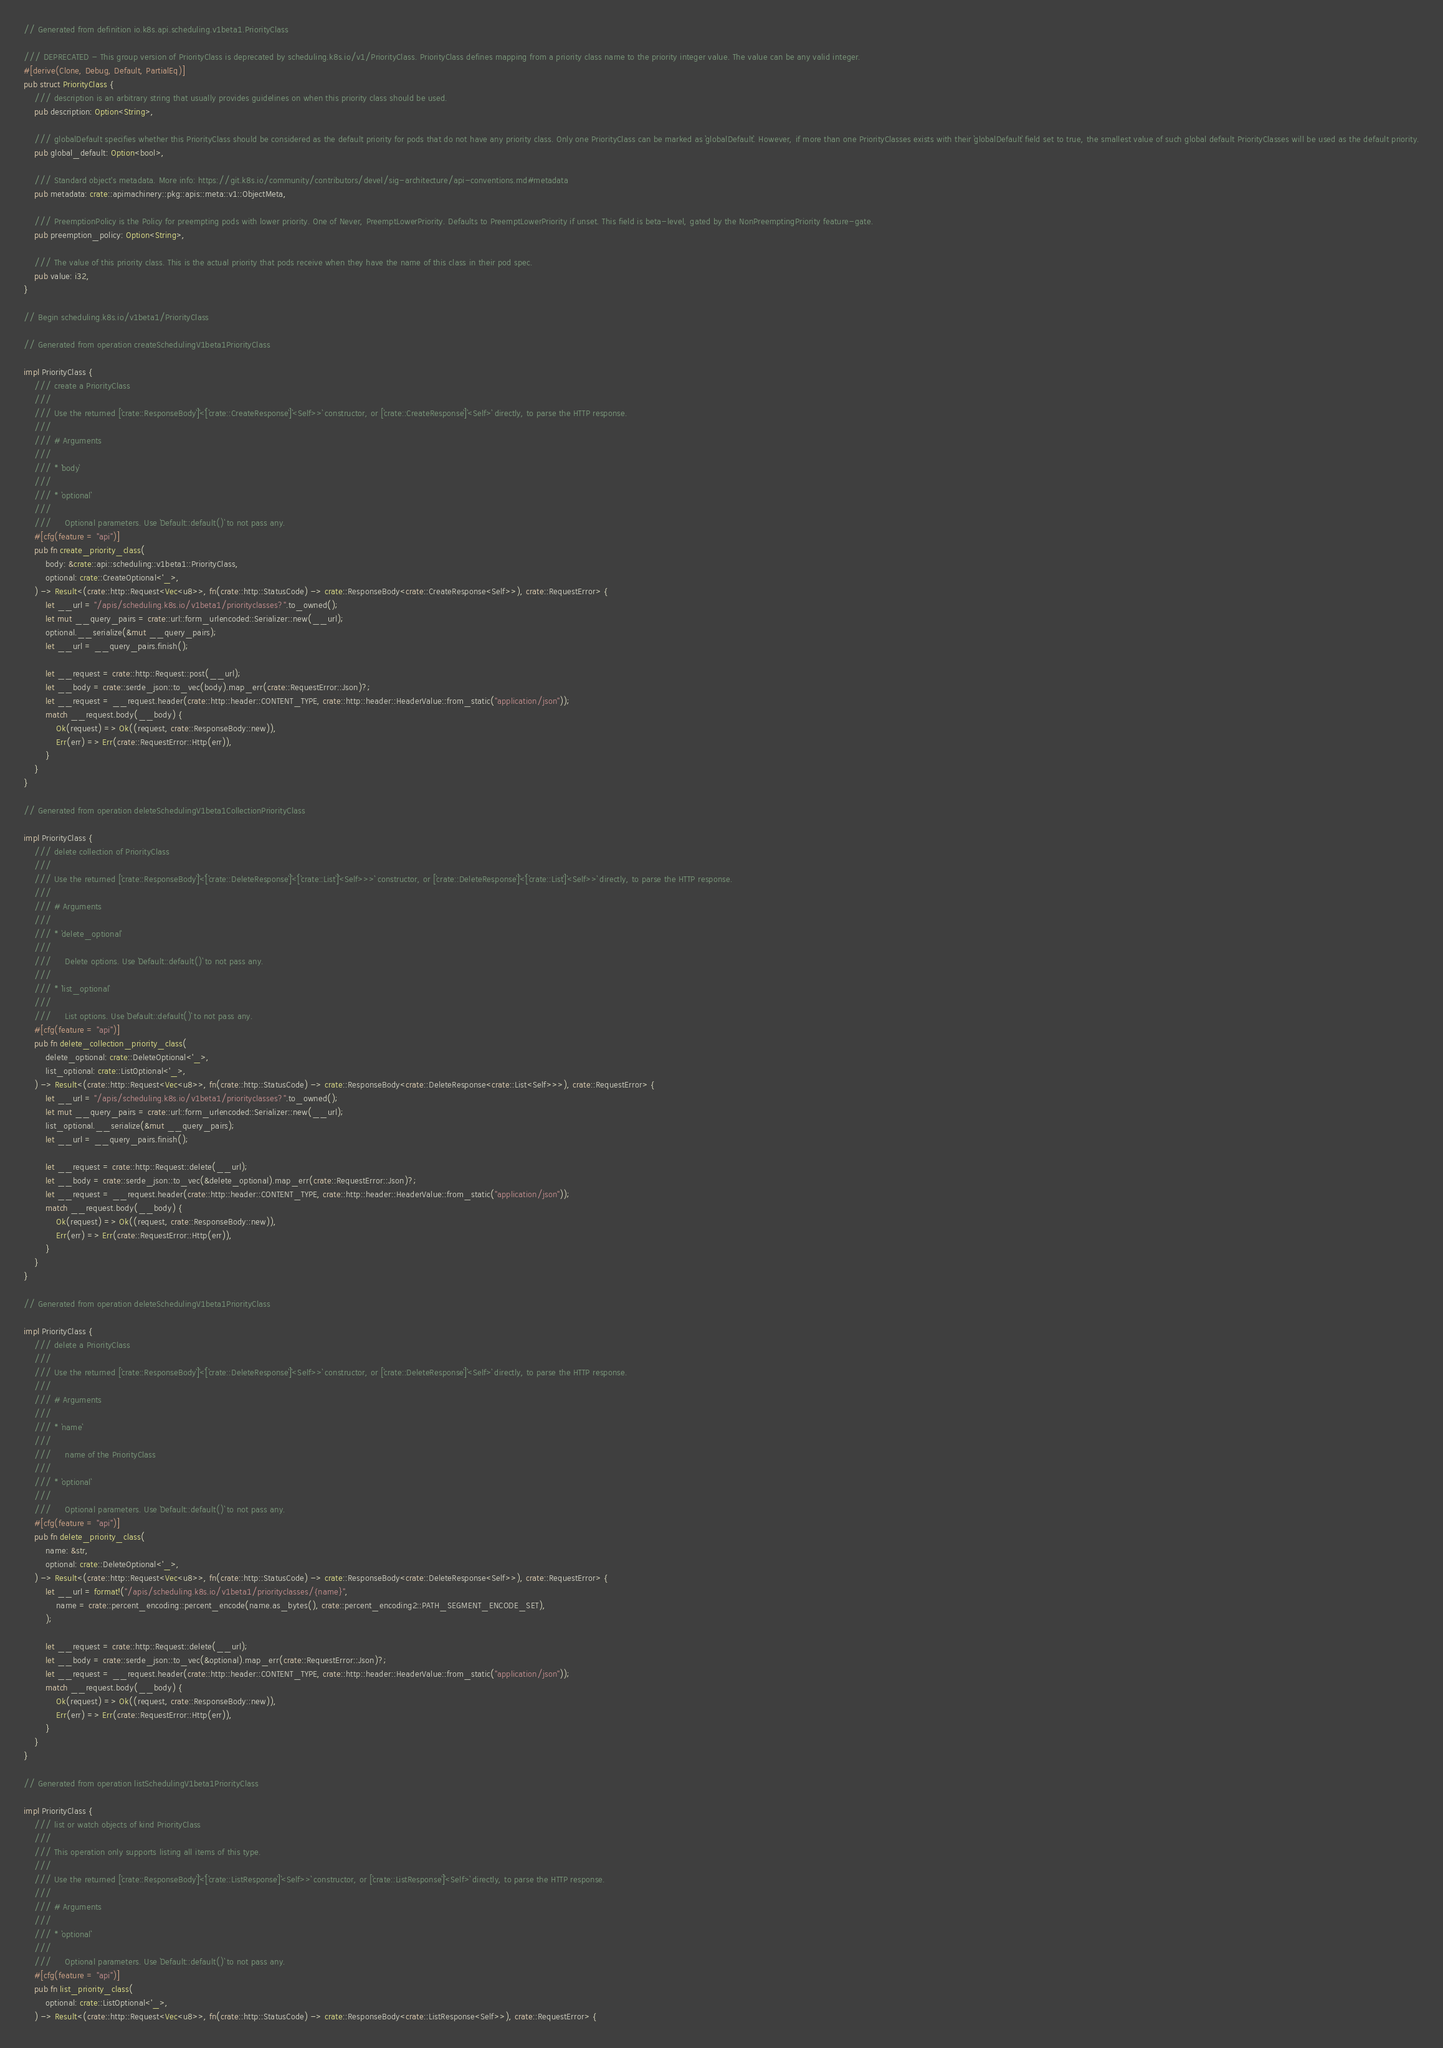<code> <loc_0><loc_0><loc_500><loc_500><_Rust_>// Generated from definition io.k8s.api.scheduling.v1beta1.PriorityClass

/// DEPRECATED - This group version of PriorityClass is deprecated by scheduling.k8s.io/v1/PriorityClass. PriorityClass defines mapping from a priority class name to the priority integer value. The value can be any valid integer.
#[derive(Clone, Debug, Default, PartialEq)]
pub struct PriorityClass {
    /// description is an arbitrary string that usually provides guidelines on when this priority class should be used.
    pub description: Option<String>,

    /// globalDefault specifies whether this PriorityClass should be considered as the default priority for pods that do not have any priority class. Only one PriorityClass can be marked as `globalDefault`. However, if more than one PriorityClasses exists with their `globalDefault` field set to true, the smallest value of such global default PriorityClasses will be used as the default priority.
    pub global_default: Option<bool>,

    /// Standard object's metadata. More info: https://git.k8s.io/community/contributors/devel/sig-architecture/api-conventions.md#metadata
    pub metadata: crate::apimachinery::pkg::apis::meta::v1::ObjectMeta,

    /// PreemptionPolicy is the Policy for preempting pods with lower priority. One of Never, PreemptLowerPriority. Defaults to PreemptLowerPriority if unset. This field is beta-level, gated by the NonPreemptingPriority feature-gate.
    pub preemption_policy: Option<String>,

    /// The value of this priority class. This is the actual priority that pods receive when they have the name of this class in their pod spec.
    pub value: i32,
}

// Begin scheduling.k8s.io/v1beta1/PriorityClass

// Generated from operation createSchedulingV1beta1PriorityClass

impl PriorityClass {
    /// create a PriorityClass
    ///
    /// Use the returned [`crate::ResponseBody`]`<`[`crate::CreateResponse`]`<Self>>` constructor, or [`crate::CreateResponse`]`<Self>` directly, to parse the HTTP response.
    ///
    /// # Arguments
    ///
    /// * `body`
    ///
    /// * `optional`
    ///
    ///     Optional parameters. Use `Default::default()` to not pass any.
    #[cfg(feature = "api")]
    pub fn create_priority_class(
        body: &crate::api::scheduling::v1beta1::PriorityClass,
        optional: crate::CreateOptional<'_>,
    ) -> Result<(crate::http::Request<Vec<u8>>, fn(crate::http::StatusCode) -> crate::ResponseBody<crate::CreateResponse<Self>>), crate::RequestError> {
        let __url = "/apis/scheduling.k8s.io/v1beta1/priorityclasses?".to_owned();
        let mut __query_pairs = crate::url::form_urlencoded::Serializer::new(__url);
        optional.__serialize(&mut __query_pairs);
        let __url = __query_pairs.finish();

        let __request = crate::http::Request::post(__url);
        let __body = crate::serde_json::to_vec(body).map_err(crate::RequestError::Json)?;
        let __request = __request.header(crate::http::header::CONTENT_TYPE, crate::http::header::HeaderValue::from_static("application/json"));
        match __request.body(__body) {
            Ok(request) => Ok((request, crate::ResponseBody::new)),
            Err(err) => Err(crate::RequestError::Http(err)),
        }
    }
}

// Generated from operation deleteSchedulingV1beta1CollectionPriorityClass

impl PriorityClass {
    /// delete collection of PriorityClass
    ///
    /// Use the returned [`crate::ResponseBody`]`<`[`crate::DeleteResponse`]`<`[`crate::List`]`<Self>>>` constructor, or [`crate::DeleteResponse`]`<`[`crate::List`]`<Self>>` directly, to parse the HTTP response.
    ///
    /// # Arguments
    ///
    /// * `delete_optional`
    ///
    ///     Delete options. Use `Default::default()` to not pass any.
    ///
    /// * `list_optional`
    ///
    ///     List options. Use `Default::default()` to not pass any.
    #[cfg(feature = "api")]
    pub fn delete_collection_priority_class(
        delete_optional: crate::DeleteOptional<'_>,
        list_optional: crate::ListOptional<'_>,
    ) -> Result<(crate::http::Request<Vec<u8>>, fn(crate::http::StatusCode) -> crate::ResponseBody<crate::DeleteResponse<crate::List<Self>>>), crate::RequestError> {
        let __url = "/apis/scheduling.k8s.io/v1beta1/priorityclasses?".to_owned();
        let mut __query_pairs = crate::url::form_urlencoded::Serializer::new(__url);
        list_optional.__serialize(&mut __query_pairs);
        let __url = __query_pairs.finish();

        let __request = crate::http::Request::delete(__url);
        let __body = crate::serde_json::to_vec(&delete_optional).map_err(crate::RequestError::Json)?;
        let __request = __request.header(crate::http::header::CONTENT_TYPE, crate::http::header::HeaderValue::from_static("application/json"));
        match __request.body(__body) {
            Ok(request) => Ok((request, crate::ResponseBody::new)),
            Err(err) => Err(crate::RequestError::Http(err)),
        }
    }
}

// Generated from operation deleteSchedulingV1beta1PriorityClass

impl PriorityClass {
    /// delete a PriorityClass
    ///
    /// Use the returned [`crate::ResponseBody`]`<`[`crate::DeleteResponse`]`<Self>>` constructor, or [`crate::DeleteResponse`]`<Self>` directly, to parse the HTTP response.
    ///
    /// # Arguments
    ///
    /// * `name`
    ///
    ///     name of the PriorityClass
    ///
    /// * `optional`
    ///
    ///     Optional parameters. Use `Default::default()` to not pass any.
    #[cfg(feature = "api")]
    pub fn delete_priority_class(
        name: &str,
        optional: crate::DeleteOptional<'_>,
    ) -> Result<(crate::http::Request<Vec<u8>>, fn(crate::http::StatusCode) -> crate::ResponseBody<crate::DeleteResponse<Self>>), crate::RequestError> {
        let __url = format!("/apis/scheduling.k8s.io/v1beta1/priorityclasses/{name}",
            name = crate::percent_encoding::percent_encode(name.as_bytes(), crate::percent_encoding2::PATH_SEGMENT_ENCODE_SET),
        );

        let __request = crate::http::Request::delete(__url);
        let __body = crate::serde_json::to_vec(&optional).map_err(crate::RequestError::Json)?;
        let __request = __request.header(crate::http::header::CONTENT_TYPE, crate::http::header::HeaderValue::from_static("application/json"));
        match __request.body(__body) {
            Ok(request) => Ok((request, crate::ResponseBody::new)),
            Err(err) => Err(crate::RequestError::Http(err)),
        }
    }
}

// Generated from operation listSchedulingV1beta1PriorityClass

impl PriorityClass {
    /// list or watch objects of kind PriorityClass
    ///
    /// This operation only supports listing all items of this type.
    ///
    /// Use the returned [`crate::ResponseBody`]`<`[`crate::ListResponse`]`<Self>>` constructor, or [`crate::ListResponse`]`<Self>` directly, to parse the HTTP response.
    ///
    /// # Arguments
    ///
    /// * `optional`
    ///
    ///     Optional parameters. Use `Default::default()` to not pass any.
    #[cfg(feature = "api")]
    pub fn list_priority_class(
        optional: crate::ListOptional<'_>,
    ) -> Result<(crate::http::Request<Vec<u8>>, fn(crate::http::StatusCode) -> crate::ResponseBody<crate::ListResponse<Self>>), crate::RequestError> {</code> 